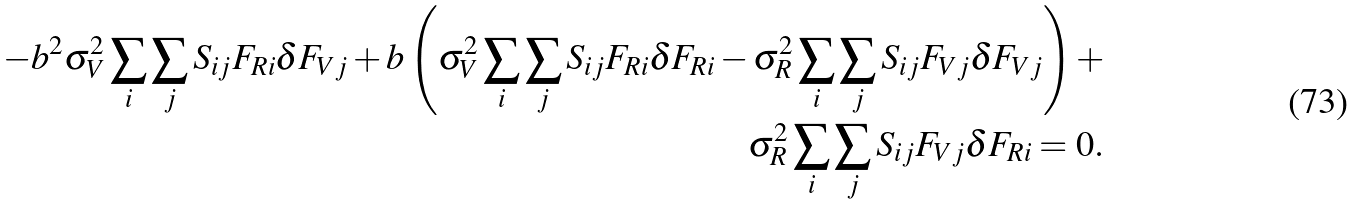<formula> <loc_0><loc_0><loc_500><loc_500>- b ^ { 2 } \sigma _ { V } ^ { 2 } \sum _ { i } \sum _ { j } S _ { i j } F _ { R i } \delta F _ { V j } + b \left ( \sigma _ { V } ^ { 2 } \sum _ { i } \sum _ { j } S _ { i j } F _ { R i } \delta F _ { R i } - \sigma _ { R } ^ { 2 } \sum _ { i } \sum _ { j } S _ { i j } F _ { V j } \delta F _ { V j } \right ) + \\ \sigma _ { R } ^ { 2 } \sum _ { i } \sum _ { j } S _ { i j } F _ { V j } \delta F _ { R i } = 0 .</formula> 